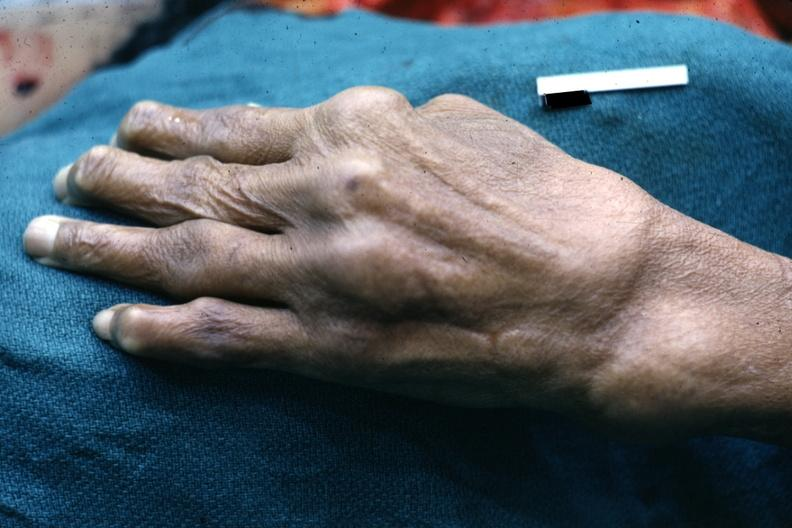re opened dysmorphic body with all organs except kidneys present?
Answer the question using a single word or phrase. No 